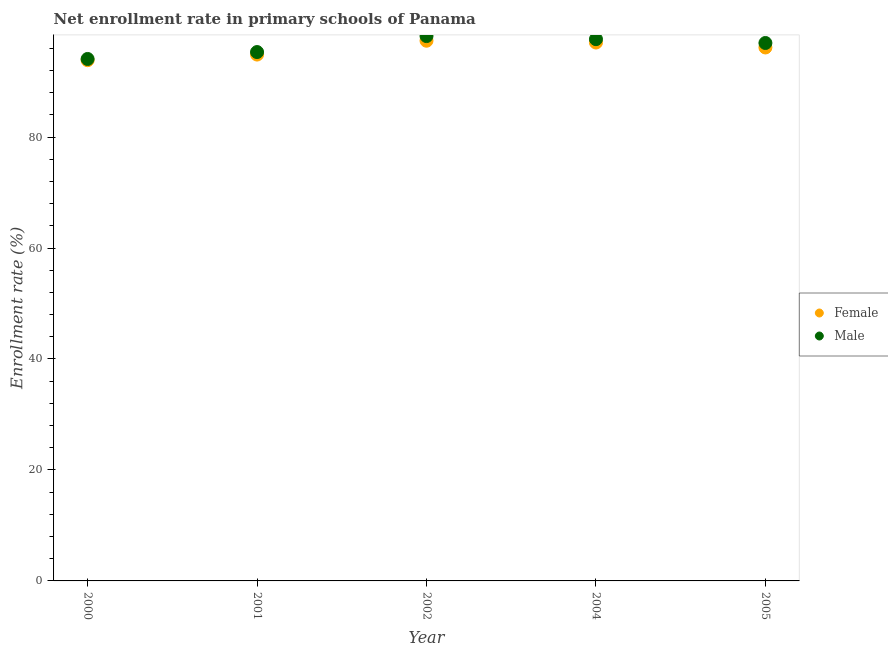How many different coloured dotlines are there?
Provide a succinct answer. 2. Is the number of dotlines equal to the number of legend labels?
Give a very brief answer. Yes. What is the enrollment rate of male students in 2005?
Give a very brief answer. 96.95. Across all years, what is the maximum enrollment rate of male students?
Give a very brief answer. 98.2. Across all years, what is the minimum enrollment rate of female students?
Make the answer very short. 93.86. What is the total enrollment rate of male students in the graph?
Provide a succinct answer. 482.2. What is the difference between the enrollment rate of female students in 2000 and that in 2001?
Offer a terse response. -1.01. What is the difference between the enrollment rate of female students in 2000 and the enrollment rate of male students in 2004?
Ensure brevity in your answer.  -3.79. What is the average enrollment rate of male students per year?
Your response must be concise. 96.44. In the year 2000, what is the difference between the enrollment rate of female students and enrollment rate of male students?
Provide a short and direct response. -0.22. In how many years, is the enrollment rate of female students greater than 52 %?
Make the answer very short. 5. What is the ratio of the enrollment rate of male students in 2001 to that in 2004?
Provide a succinct answer. 0.98. Is the difference between the enrollment rate of female students in 2004 and 2005 greater than the difference between the enrollment rate of male students in 2004 and 2005?
Your answer should be very brief. Yes. What is the difference between the highest and the second highest enrollment rate of male students?
Ensure brevity in your answer.  0.55. What is the difference between the highest and the lowest enrollment rate of male students?
Make the answer very short. 4.13. In how many years, is the enrollment rate of female students greater than the average enrollment rate of female students taken over all years?
Provide a short and direct response. 3. Does the enrollment rate of male students monotonically increase over the years?
Keep it short and to the point. No. Is the enrollment rate of male students strictly greater than the enrollment rate of female students over the years?
Your answer should be compact. Yes. How many dotlines are there?
Your response must be concise. 2. What is the difference between two consecutive major ticks on the Y-axis?
Your answer should be compact. 20. Does the graph contain any zero values?
Give a very brief answer. No. What is the title of the graph?
Ensure brevity in your answer.  Net enrollment rate in primary schools of Panama. What is the label or title of the Y-axis?
Offer a very short reply. Enrollment rate (%). What is the Enrollment rate (%) of Female in 2000?
Keep it short and to the point. 93.86. What is the Enrollment rate (%) of Male in 2000?
Your answer should be very brief. 94.08. What is the Enrollment rate (%) in Female in 2001?
Keep it short and to the point. 94.87. What is the Enrollment rate (%) of Male in 2001?
Ensure brevity in your answer.  95.32. What is the Enrollment rate (%) of Female in 2002?
Your response must be concise. 97.36. What is the Enrollment rate (%) in Male in 2002?
Ensure brevity in your answer.  98.2. What is the Enrollment rate (%) in Female in 2004?
Make the answer very short. 97.04. What is the Enrollment rate (%) of Male in 2004?
Your answer should be very brief. 97.65. What is the Enrollment rate (%) in Female in 2005?
Your response must be concise. 96.15. What is the Enrollment rate (%) of Male in 2005?
Offer a very short reply. 96.95. Across all years, what is the maximum Enrollment rate (%) in Female?
Offer a terse response. 97.36. Across all years, what is the maximum Enrollment rate (%) in Male?
Keep it short and to the point. 98.2. Across all years, what is the minimum Enrollment rate (%) in Female?
Offer a terse response. 93.86. Across all years, what is the minimum Enrollment rate (%) of Male?
Make the answer very short. 94.08. What is the total Enrollment rate (%) of Female in the graph?
Ensure brevity in your answer.  479.28. What is the total Enrollment rate (%) of Male in the graph?
Provide a short and direct response. 482.2. What is the difference between the Enrollment rate (%) of Female in 2000 and that in 2001?
Provide a short and direct response. -1.01. What is the difference between the Enrollment rate (%) of Male in 2000 and that in 2001?
Ensure brevity in your answer.  -1.25. What is the difference between the Enrollment rate (%) of Female in 2000 and that in 2002?
Your answer should be compact. -3.5. What is the difference between the Enrollment rate (%) of Male in 2000 and that in 2002?
Keep it short and to the point. -4.13. What is the difference between the Enrollment rate (%) in Female in 2000 and that in 2004?
Make the answer very short. -3.18. What is the difference between the Enrollment rate (%) in Male in 2000 and that in 2004?
Provide a succinct answer. -3.57. What is the difference between the Enrollment rate (%) in Female in 2000 and that in 2005?
Make the answer very short. -2.29. What is the difference between the Enrollment rate (%) in Male in 2000 and that in 2005?
Give a very brief answer. -2.88. What is the difference between the Enrollment rate (%) in Female in 2001 and that in 2002?
Provide a short and direct response. -2.49. What is the difference between the Enrollment rate (%) of Male in 2001 and that in 2002?
Keep it short and to the point. -2.88. What is the difference between the Enrollment rate (%) in Female in 2001 and that in 2004?
Offer a terse response. -2.17. What is the difference between the Enrollment rate (%) in Male in 2001 and that in 2004?
Offer a very short reply. -2.32. What is the difference between the Enrollment rate (%) in Female in 2001 and that in 2005?
Give a very brief answer. -1.28. What is the difference between the Enrollment rate (%) of Male in 2001 and that in 2005?
Offer a very short reply. -1.63. What is the difference between the Enrollment rate (%) of Female in 2002 and that in 2004?
Your response must be concise. 0.33. What is the difference between the Enrollment rate (%) of Male in 2002 and that in 2004?
Ensure brevity in your answer.  0.55. What is the difference between the Enrollment rate (%) in Female in 2002 and that in 2005?
Keep it short and to the point. 1.21. What is the difference between the Enrollment rate (%) of Male in 2002 and that in 2005?
Offer a terse response. 1.25. What is the difference between the Enrollment rate (%) in Female in 2004 and that in 2005?
Provide a succinct answer. 0.89. What is the difference between the Enrollment rate (%) of Male in 2004 and that in 2005?
Offer a terse response. 0.69. What is the difference between the Enrollment rate (%) in Female in 2000 and the Enrollment rate (%) in Male in 2001?
Give a very brief answer. -1.46. What is the difference between the Enrollment rate (%) in Female in 2000 and the Enrollment rate (%) in Male in 2002?
Your answer should be very brief. -4.34. What is the difference between the Enrollment rate (%) in Female in 2000 and the Enrollment rate (%) in Male in 2004?
Offer a terse response. -3.79. What is the difference between the Enrollment rate (%) in Female in 2000 and the Enrollment rate (%) in Male in 2005?
Provide a short and direct response. -3.1. What is the difference between the Enrollment rate (%) of Female in 2001 and the Enrollment rate (%) of Male in 2002?
Your answer should be very brief. -3.33. What is the difference between the Enrollment rate (%) in Female in 2001 and the Enrollment rate (%) in Male in 2004?
Offer a terse response. -2.78. What is the difference between the Enrollment rate (%) in Female in 2001 and the Enrollment rate (%) in Male in 2005?
Ensure brevity in your answer.  -2.09. What is the difference between the Enrollment rate (%) of Female in 2002 and the Enrollment rate (%) of Male in 2004?
Make the answer very short. -0.28. What is the difference between the Enrollment rate (%) in Female in 2002 and the Enrollment rate (%) in Male in 2005?
Keep it short and to the point. 0.41. What is the difference between the Enrollment rate (%) in Female in 2004 and the Enrollment rate (%) in Male in 2005?
Offer a very short reply. 0.08. What is the average Enrollment rate (%) of Female per year?
Ensure brevity in your answer.  95.86. What is the average Enrollment rate (%) of Male per year?
Your answer should be compact. 96.44. In the year 2000, what is the difference between the Enrollment rate (%) of Female and Enrollment rate (%) of Male?
Make the answer very short. -0.22. In the year 2001, what is the difference between the Enrollment rate (%) of Female and Enrollment rate (%) of Male?
Provide a short and direct response. -0.45. In the year 2002, what is the difference between the Enrollment rate (%) of Female and Enrollment rate (%) of Male?
Provide a succinct answer. -0.84. In the year 2004, what is the difference between the Enrollment rate (%) in Female and Enrollment rate (%) in Male?
Your answer should be very brief. -0.61. In the year 2005, what is the difference between the Enrollment rate (%) of Female and Enrollment rate (%) of Male?
Give a very brief answer. -0.81. What is the ratio of the Enrollment rate (%) in Male in 2000 to that in 2001?
Give a very brief answer. 0.99. What is the ratio of the Enrollment rate (%) of Male in 2000 to that in 2002?
Offer a terse response. 0.96. What is the ratio of the Enrollment rate (%) in Female in 2000 to that in 2004?
Offer a terse response. 0.97. What is the ratio of the Enrollment rate (%) in Male in 2000 to that in 2004?
Offer a terse response. 0.96. What is the ratio of the Enrollment rate (%) in Female in 2000 to that in 2005?
Keep it short and to the point. 0.98. What is the ratio of the Enrollment rate (%) of Male in 2000 to that in 2005?
Make the answer very short. 0.97. What is the ratio of the Enrollment rate (%) in Female in 2001 to that in 2002?
Give a very brief answer. 0.97. What is the ratio of the Enrollment rate (%) in Male in 2001 to that in 2002?
Keep it short and to the point. 0.97. What is the ratio of the Enrollment rate (%) of Female in 2001 to that in 2004?
Provide a succinct answer. 0.98. What is the ratio of the Enrollment rate (%) of Male in 2001 to that in 2004?
Provide a short and direct response. 0.98. What is the ratio of the Enrollment rate (%) in Female in 2001 to that in 2005?
Offer a terse response. 0.99. What is the ratio of the Enrollment rate (%) of Male in 2001 to that in 2005?
Provide a short and direct response. 0.98. What is the ratio of the Enrollment rate (%) in Female in 2002 to that in 2005?
Provide a short and direct response. 1.01. What is the ratio of the Enrollment rate (%) of Male in 2002 to that in 2005?
Offer a very short reply. 1.01. What is the ratio of the Enrollment rate (%) of Female in 2004 to that in 2005?
Give a very brief answer. 1.01. What is the ratio of the Enrollment rate (%) in Male in 2004 to that in 2005?
Ensure brevity in your answer.  1.01. What is the difference between the highest and the second highest Enrollment rate (%) of Female?
Provide a short and direct response. 0.33. What is the difference between the highest and the second highest Enrollment rate (%) of Male?
Offer a very short reply. 0.55. What is the difference between the highest and the lowest Enrollment rate (%) of Female?
Your answer should be very brief. 3.5. What is the difference between the highest and the lowest Enrollment rate (%) in Male?
Provide a short and direct response. 4.13. 